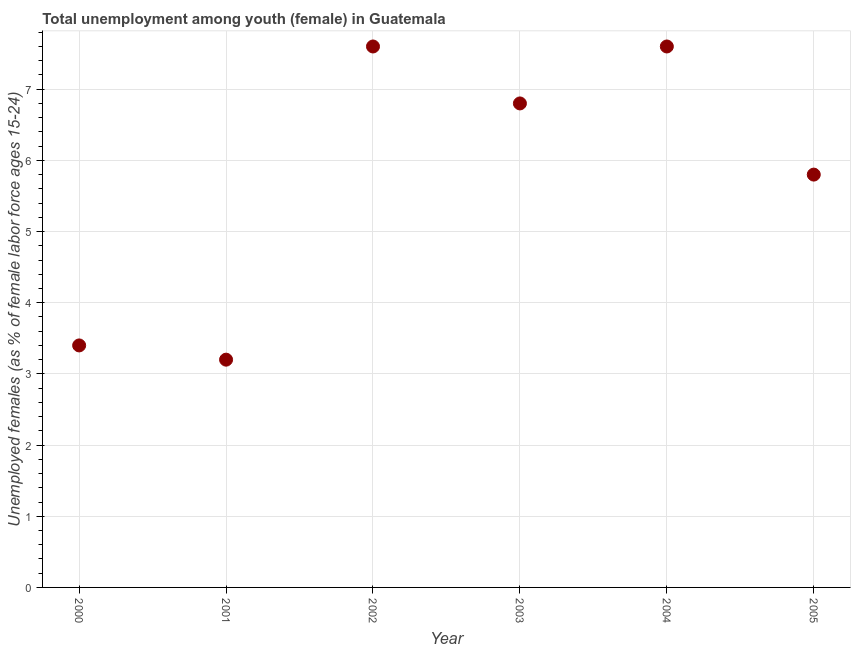What is the unemployed female youth population in 2004?
Offer a terse response. 7.6. Across all years, what is the maximum unemployed female youth population?
Offer a very short reply. 7.6. Across all years, what is the minimum unemployed female youth population?
Your answer should be compact. 3.2. What is the sum of the unemployed female youth population?
Offer a terse response. 34.4. What is the difference between the unemployed female youth population in 2000 and 2002?
Give a very brief answer. -4.2. What is the average unemployed female youth population per year?
Your answer should be very brief. 5.73. What is the median unemployed female youth population?
Offer a very short reply. 6.3. What is the ratio of the unemployed female youth population in 2000 to that in 2004?
Provide a succinct answer. 0.45. Is the difference between the unemployed female youth population in 2000 and 2005 greater than the difference between any two years?
Your answer should be compact. No. What is the difference between the highest and the lowest unemployed female youth population?
Your answer should be very brief. 4.4. Does the unemployed female youth population monotonically increase over the years?
Offer a terse response. No. How many dotlines are there?
Provide a succinct answer. 1. How many years are there in the graph?
Make the answer very short. 6. What is the difference between two consecutive major ticks on the Y-axis?
Offer a terse response. 1. Does the graph contain any zero values?
Keep it short and to the point. No. Does the graph contain grids?
Provide a short and direct response. Yes. What is the title of the graph?
Offer a terse response. Total unemployment among youth (female) in Guatemala. What is the label or title of the X-axis?
Provide a succinct answer. Year. What is the label or title of the Y-axis?
Give a very brief answer. Unemployed females (as % of female labor force ages 15-24). What is the Unemployed females (as % of female labor force ages 15-24) in 2000?
Give a very brief answer. 3.4. What is the Unemployed females (as % of female labor force ages 15-24) in 2001?
Make the answer very short. 3.2. What is the Unemployed females (as % of female labor force ages 15-24) in 2002?
Your response must be concise. 7.6. What is the Unemployed females (as % of female labor force ages 15-24) in 2003?
Offer a terse response. 6.8. What is the Unemployed females (as % of female labor force ages 15-24) in 2004?
Provide a succinct answer. 7.6. What is the Unemployed females (as % of female labor force ages 15-24) in 2005?
Keep it short and to the point. 5.8. What is the difference between the Unemployed females (as % of female labor force ages 15-24) in 2000 and 2002?
Offer a very short reply. -4.2. What is the difference between the Unemployed females (as % of female labor force ages 15-24) in 2001 and 2002?
Provide a short and direct response. -4.4. What is the difference between the Unemployed females (as % of female labor force ages 15-24) in 2001 and 2003?
Offer a very short reply. -3.6. What is the difference between the Unemployed females (as % of female labor force ages 15-24) in 2002 and 2005?
Ensure brevity in your answer.  1.8. What is the difference between the Unemployed females (as % of female labor force ages 15-24) in 2003 and 2005?
Ensure brevity in your answer.  1. What is the difference between the Unemployed females (as % of female labor force ages 15-24) in 2004 and 2005?
Provide a short and direct response. 1.8. What is the ratio of the Unemployed females (as % of female labor force ages 15-24) in 2000 to that in 2001?
Provide a succinct answer. 1.06. What is the ratio of the Unemployed females (as % of female labor force ages 15-24) in 2000 to that in 2002?
Give a very brief answer. 0.45. What is the ratio of the Unemployed females (as % of female labor force ages 15-24) in 2000 to that in 2004?
Your answer should be compact. 0.45. What is the ratio of the Unemployed females (as % of female labor force ages 15-24) in 2000 to that in 2005?
Offer a very short reply. 0.59. What is the ratio of the Unemployed females (as % of female labor force ages 15-24) in 2001 to that in 2002?
Provide a succinct answer. 0.42. What is the ratio of the Unemployed females (as % of female labor force ages 15-24) in 2001 to that in 2003?
Keep it short and to the point. 0.47. What is the ratio of the Unemployed females (as % of female labor force ages 15-24) in 2001 to that in 2004?
Make the answer very short. 0.42. What is the ratio of the Unemployed females (as % of female labor force ages 15-24) in 2001 to that in 2005?
Ensure brevity in your answer.  0.55. What is the ratio of the Unemployed females (as % of female labor force ages 15-24) in 2002 to that in 2003?
Provide a succinct answer. 1.12. What is the ratio of the Unemployed females (as % of female labor force ages 15-24) in 2002 to that in 2004?
Give a very brief answer. 1. What is the ratio of the Unemployed females (as % of female labor force ages 15-24) in 2002 to that in 2005?
Provide a short and direct response. 1.31. What is the ratio of the Unemployed females (as % of female labor force ages 15-24) in 2003 to that in 2004?
Your answer should be compact. 0.9. What is the ratio of the Unemployed females (as % of female labor force ages 15-24) in 2003 to that in 2005?
Ensure brevity in your answer.  1.17. What is the ratio of the Unemployed females (as % of female labor force ages 15-24) in 2004 to that in 2005?
Ensure brevity in your answer.  1.31. 